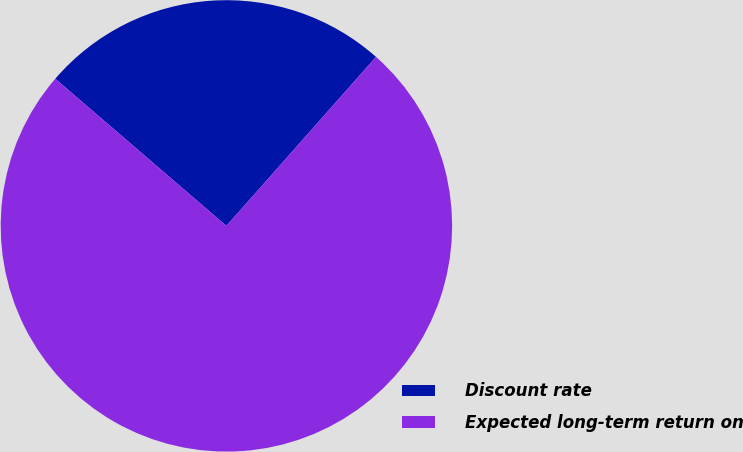Convert chart to OTSL. <chart><loc_0><loc_0><loc_500><loc_500><pie_chart><fcel>Discount rate<fcel>Expected long-term return on<nl><fcel>25.23%<fcel>74.77%<nl></chart> 